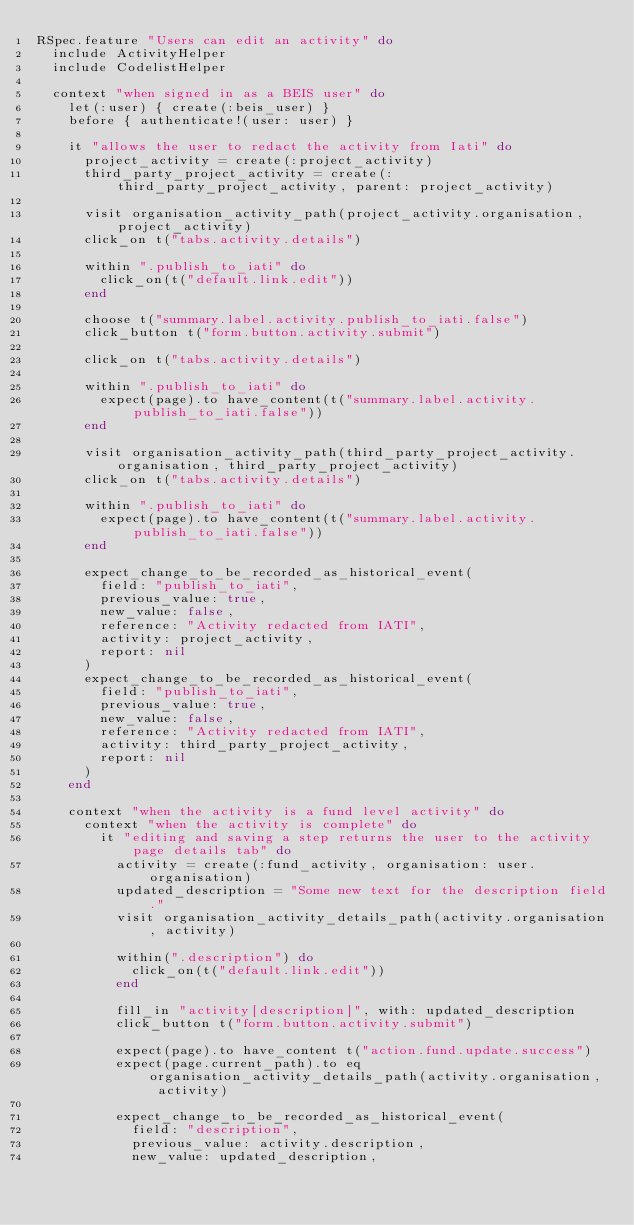Convert code to text. <code><loc_0><loc_0><loc_500><loc_500><_Ruby_>RSpec.feature "Users can edit an activity" do
  include ActivityHelper
  include CodelistHelper

  context "when signed in as a BEIS user" do
    let(:user) { create(:beis_user) }
    before { authenticate!(user: user) }

    it "allows the user to redact the activity from Iati" do
      project_activity = create(:project_activity)
      third_party_project_activity = create(:third_party_project_activity, parent: project_activity)

      visit organisation_activity_path(project_activity.organisation, project_activity)
      click_on t("tabs.activity.details")

      within ".publish_to_iati" do
        click_on(t("default.link.edit"))
      end

      choose t("summary.label.activity.publish_to_iati.false")
      click_button t("form.button.activity.submit")

      click_on t("tabs.activity.details")

      within ".publish_to_iati" do
        expect(page).to have_content(t("summary.label.activity.publish_to_iati.false"))
      end

      visit organisation_activity_path(third_party_project_activity.organisation, third_party_project_activity)
      click_on t("tabs.activity.details")

      within ".publish_to_iati" do
        expect(page).to have_content(t("summary.label.activity.publish_to_iati.false"))
      end

      expect_change_to_be_recorded_as_historical_event(
        field: "publish_to_iati",
        previous_value: true,
        new_value: false,
        reference: "Activity redacted from IATI",
        activity: project_activity,
        report: nil
      )
      expect_change_to_be_recorded_as_historical_event(
        field: "publish_to_iati",
        previous_value: true,
        new_value: false,
        reference: "Activity redacted from IATI",
        activity: third_party_project_activity,
        report: nil
      )
    end

    context "when the activity is a fund level activity" do
      context "when the activity is complete" do
        it "editing and saving a step returns the user to the activity page details tab" do
          activity = create(:fund_activity, organisation: user.organisation)
          updated_description = "Some new text for the description field."
          visit organisation_activity_details_path(activity.organisation, activity)

          within(".description") do
            click_on(t("default.link.edit"))
          end

          fill_in "activity[description]", with: updated_description
          click_button t("form.button.activity.submit")

          expect(page).to have_content t("action.fund.update.success")
          expect(page.current_path).to eq organisation_activity_details_path(activity.organisation, activity)

          expect_change_to_be_recorded_as_historical_event(
            field: "description",
            previous_value: activity.description,
            new_value: updated_description,</code> 